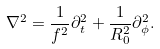Convert formula to latex. <formula><loc_0><loc_0><loc_500><loc_500>\nabla ^ { 2 } = \frac { 1 } { f ^ { 2 } } \partial ^ { 2 } _ { t } + \frac { 1 } { R _ { 0 } ^ { 2 } } \partial ^ { 2 } _ { \phi } .</formula> 